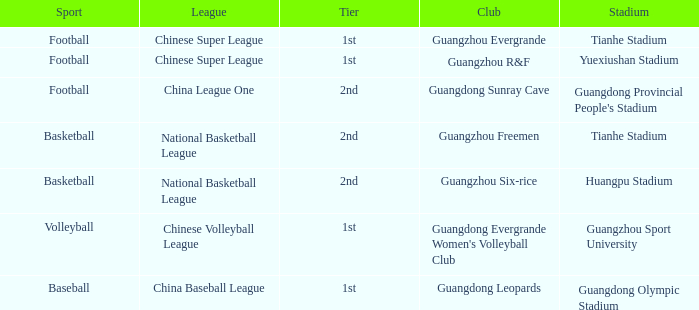Which rank is for football at tianhe stadium? 1st. 